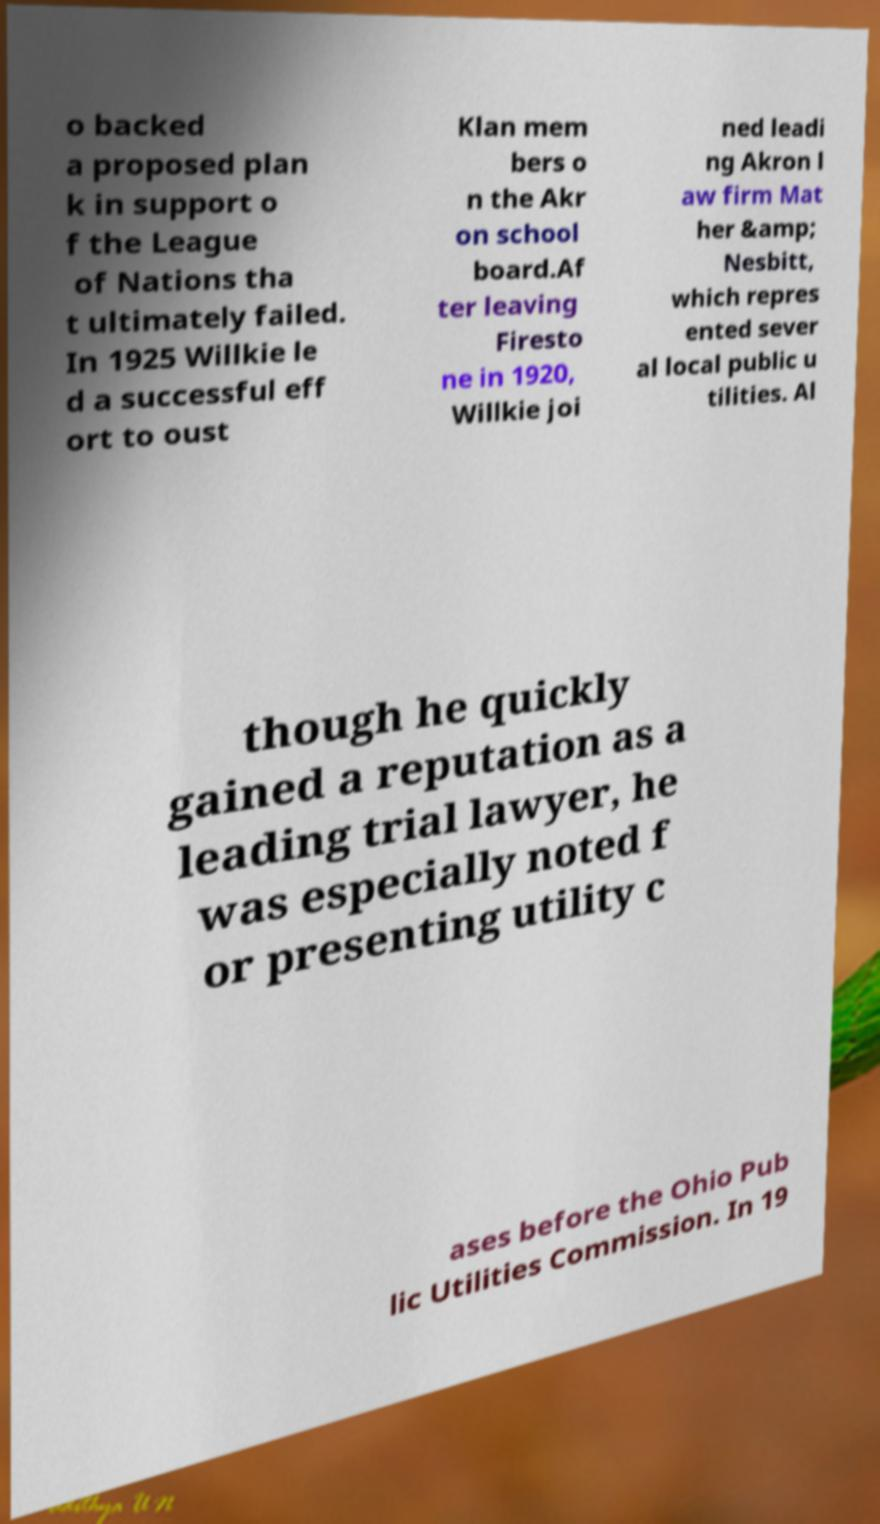For documentation purposes, I need the text within this image transcribed. Could you provide that? o backed a proposed plan k in support o f the League of Nations tha t ultimately failed. In 1925 Willkie le d a successful eff ort to oust Klan mem bers o n the Akr on school board.Af ter leaving Firesto ne in 1920, Willkie joi ned leadi ng Akron l aw firm Mat her &amp; Nesbitt, which repres ented sever al local public u tilities. Al though he quickly gained a reputation as a leading trial lawyer, he was especially noted f or presenting utility c ases before the Ohio Pub lic Utilities Commission. In 19 